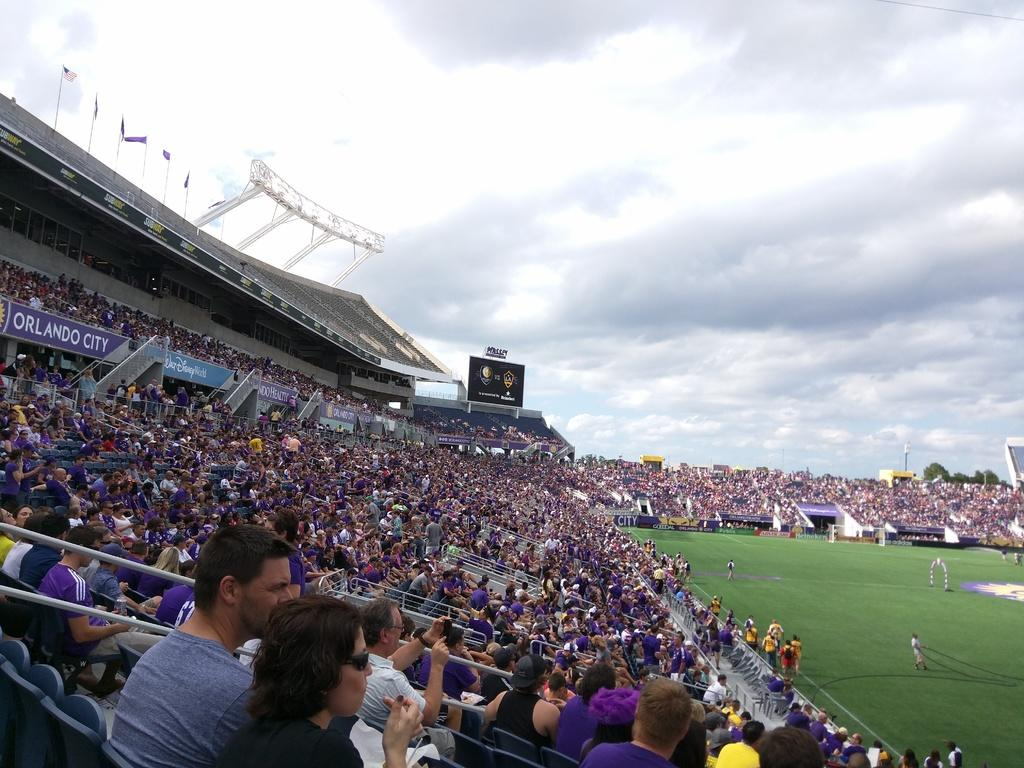What activity are the people engaged in at the stadium? The people are sitting at the stadium, watching something on the ground. What can be seen on the top of the stadium? There are flags on the top of the stadium. How many legs can be seen on the people in the image? The number of legs cannot be determined from the image, as only the upper bodies of the people are visible. 